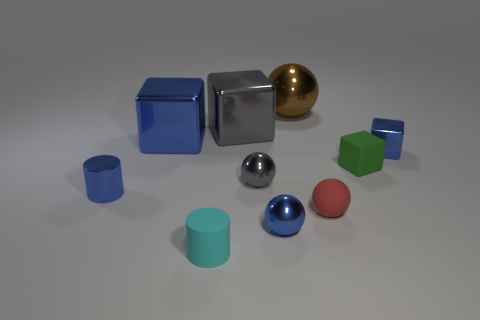There is a blue metal cube that is left of the cyan matte cylinder; is its size the same as the gray cube?
Give a very brief answer. Yes. What number of things are both left of the red rubber thing and to the right of the cyan rubber cylinder?
Give a very brief answer. 4. There is a cube that is to the right of the small rubber thing on the right side of the small rubber sphere; how big is it?
Give a very brief answer. Small. Is the number of gray objects on the left side of the large gray cube less than the number of rubber blocks to the left of the small matte sphere?
Your answer should be compact. No. There is a metallic cube on the right side of the small gray metallic ball; is it the same color as the matte object that is to the left of the large brown metallic object?
Offer a terse response. No. There is a tiny thing that is left of the small gray ball and behind the cyan thing; what is it made of?
Provide a short and direct response. Metal. Are any tiny metallic cylinders visible?
Provide a short and direct response. Yes. There is a cyan object that is the same material as the small red object; what is its shape?
Provide a succinct answer. Cylinder. There is a big gray object; is it the same shape as the tiny blue thing on the right side of the blue ball?
Offer a terse response. Yes. There is a cylinder that is right of the blue block that is left of the big gray object; what is it made of?
Your answer should be very brief. Rubber. 